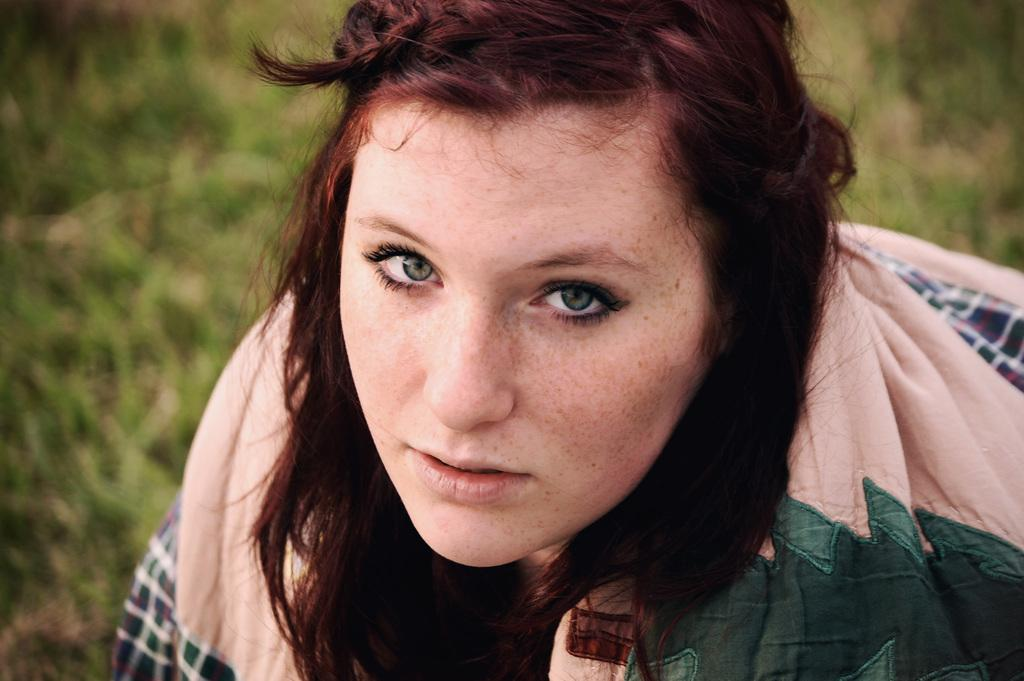Who is present in the image? There is a woman in the image. What type of environment is visible in the image? There is grass visible in the image, suggesting an outdoor setting. What is the flavor of the news being read by the woman in the image? There is no news or any indication of reading in the image, so it is not possible to determine the flavor of any news. 